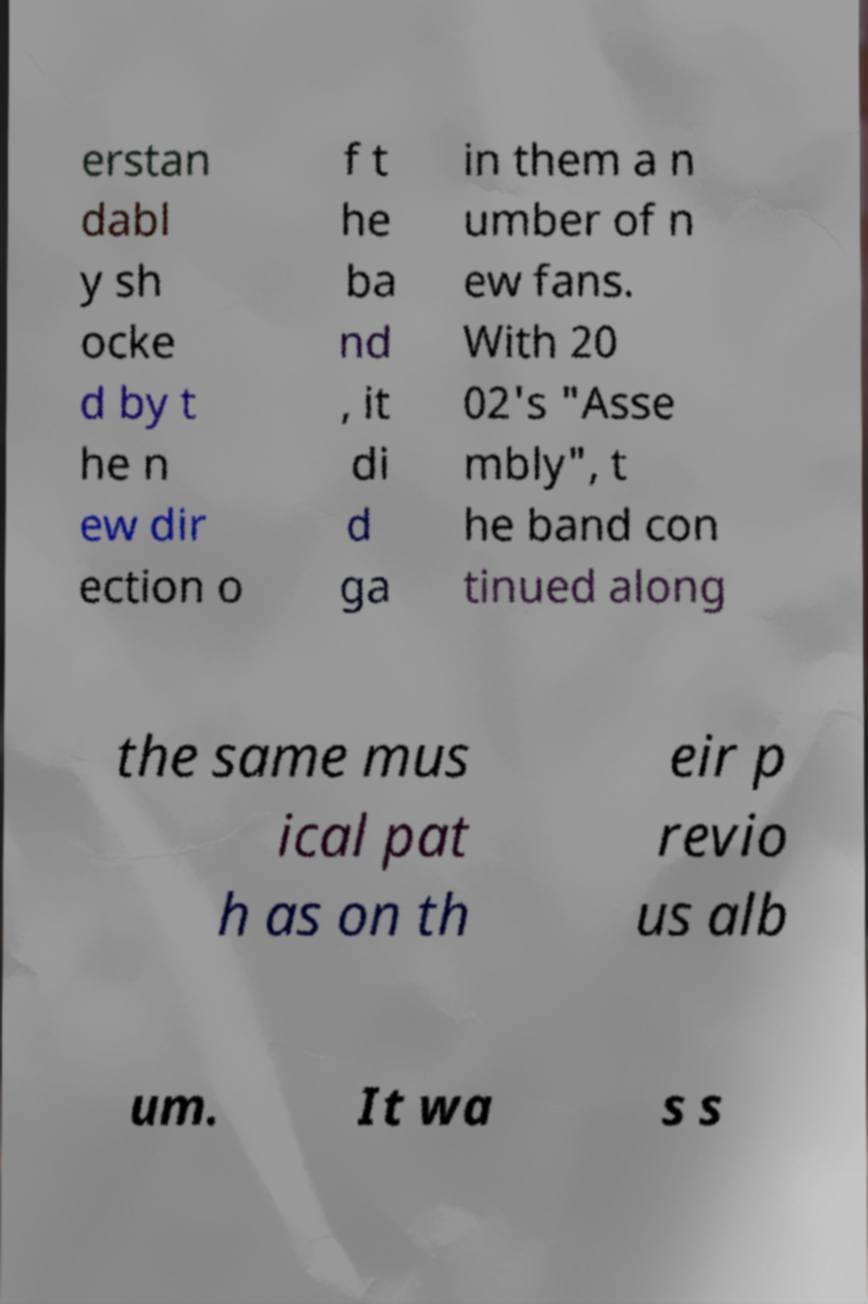Could you extract and type out the text from this image? erstan dabl y sh ocke d by t he n ew dir ection o f t he ba nd , it di d ga in them a n umber of n ew fans. With 20 02's "Asse mbly", t he band con tinued along the same mus ical pat h as on th eir p revio us alb um. It wa s s 